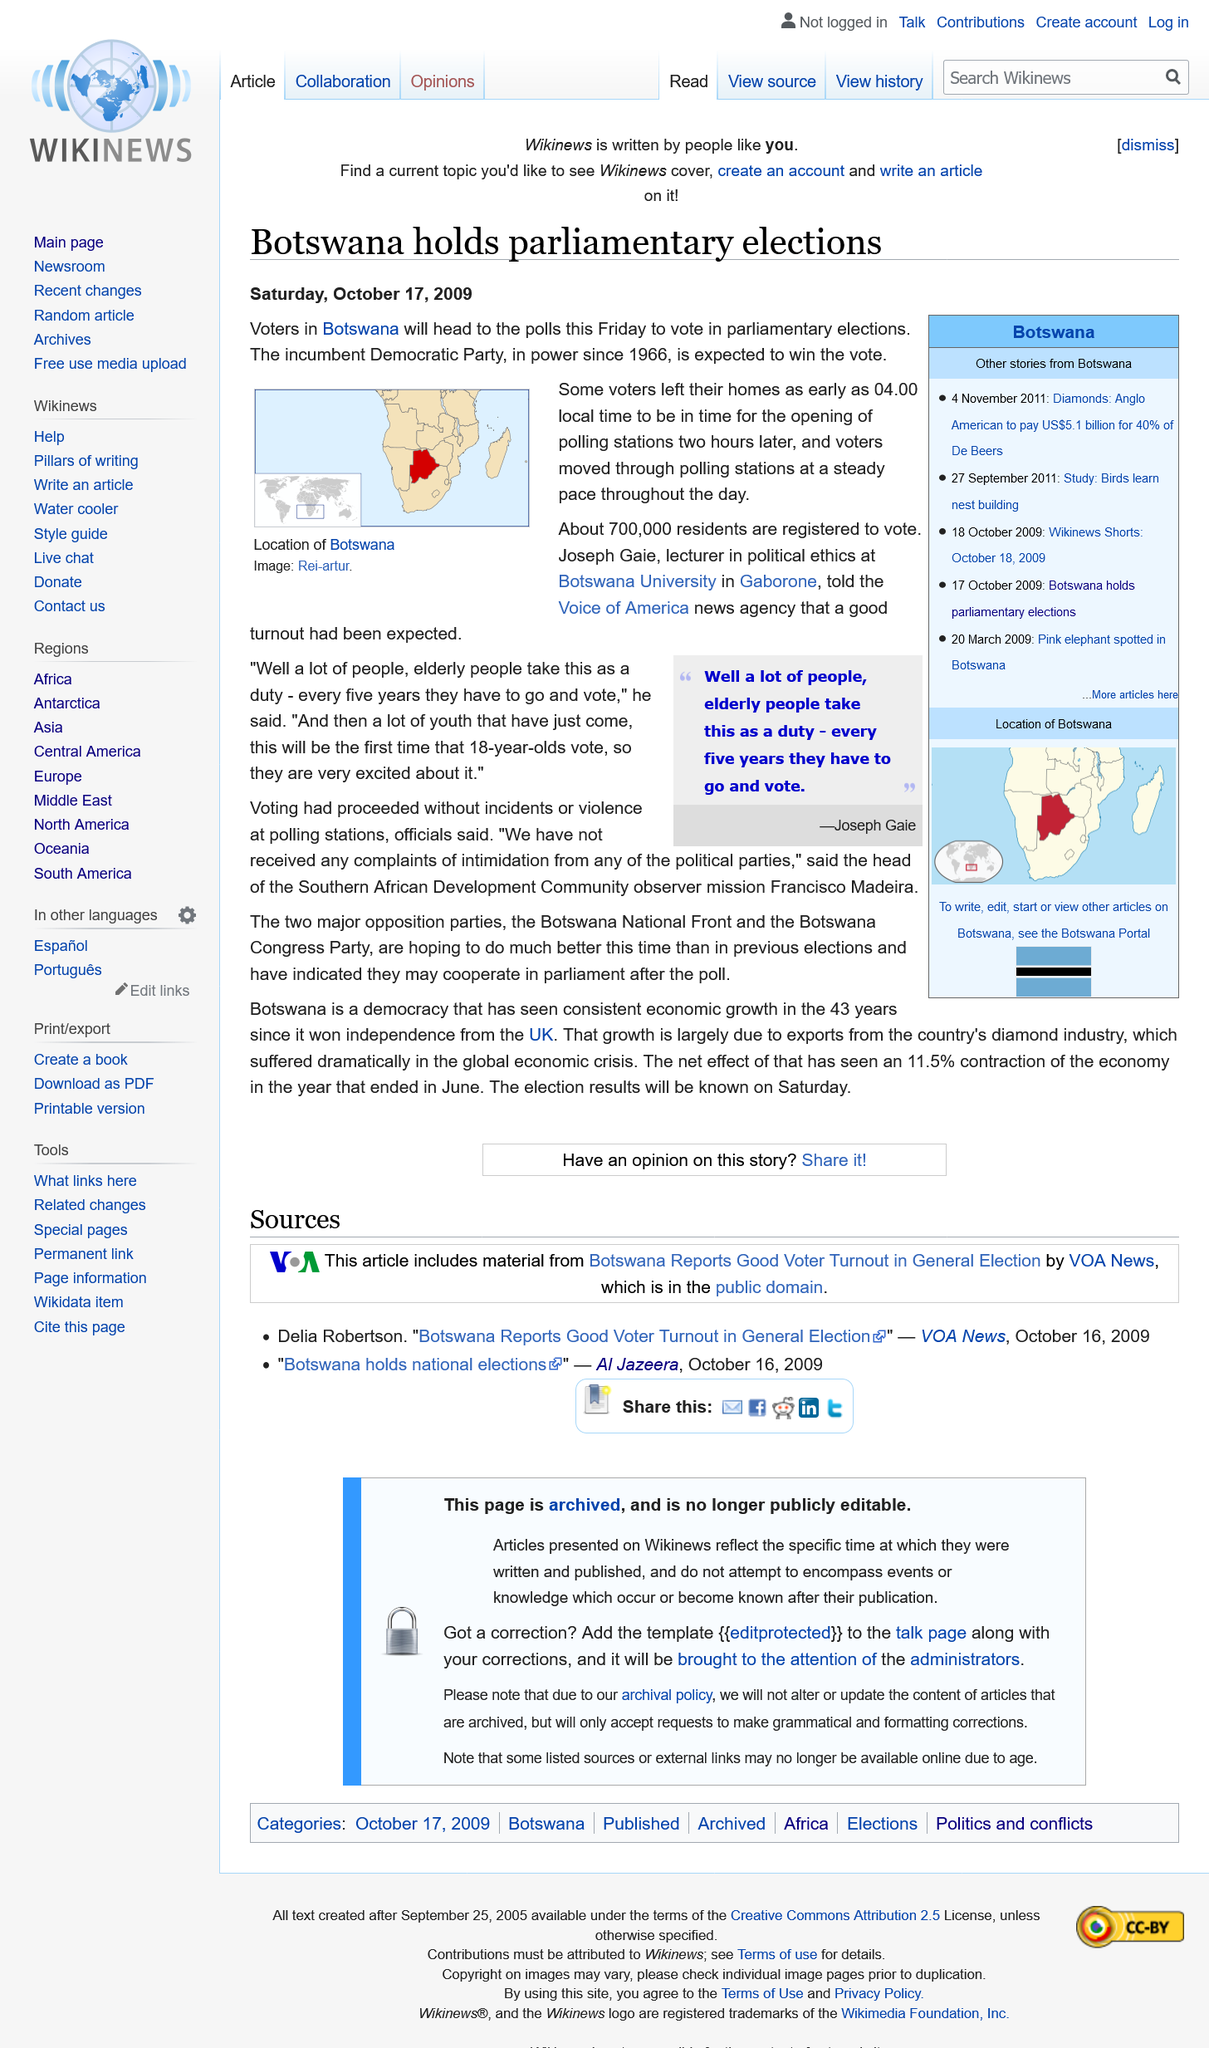Draw attention to some important aspects in this diagram. In the parliamentary elections in Botswana, approximately 700,000 residents are registered and eligible to vote, constituting a significant portion of the electorate. The polling stations in Botswana opened at 6:00 a.m. The Democratic Party is predicted to emerge victorious in the parliamentary elections in Botswana, as they are the incumbent party and are expected to maintain their stronghold on power. 